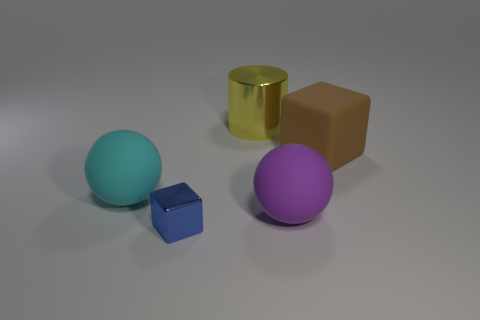Is the number of green rubber blocks less than the number of big cyan rubber objects? yes 